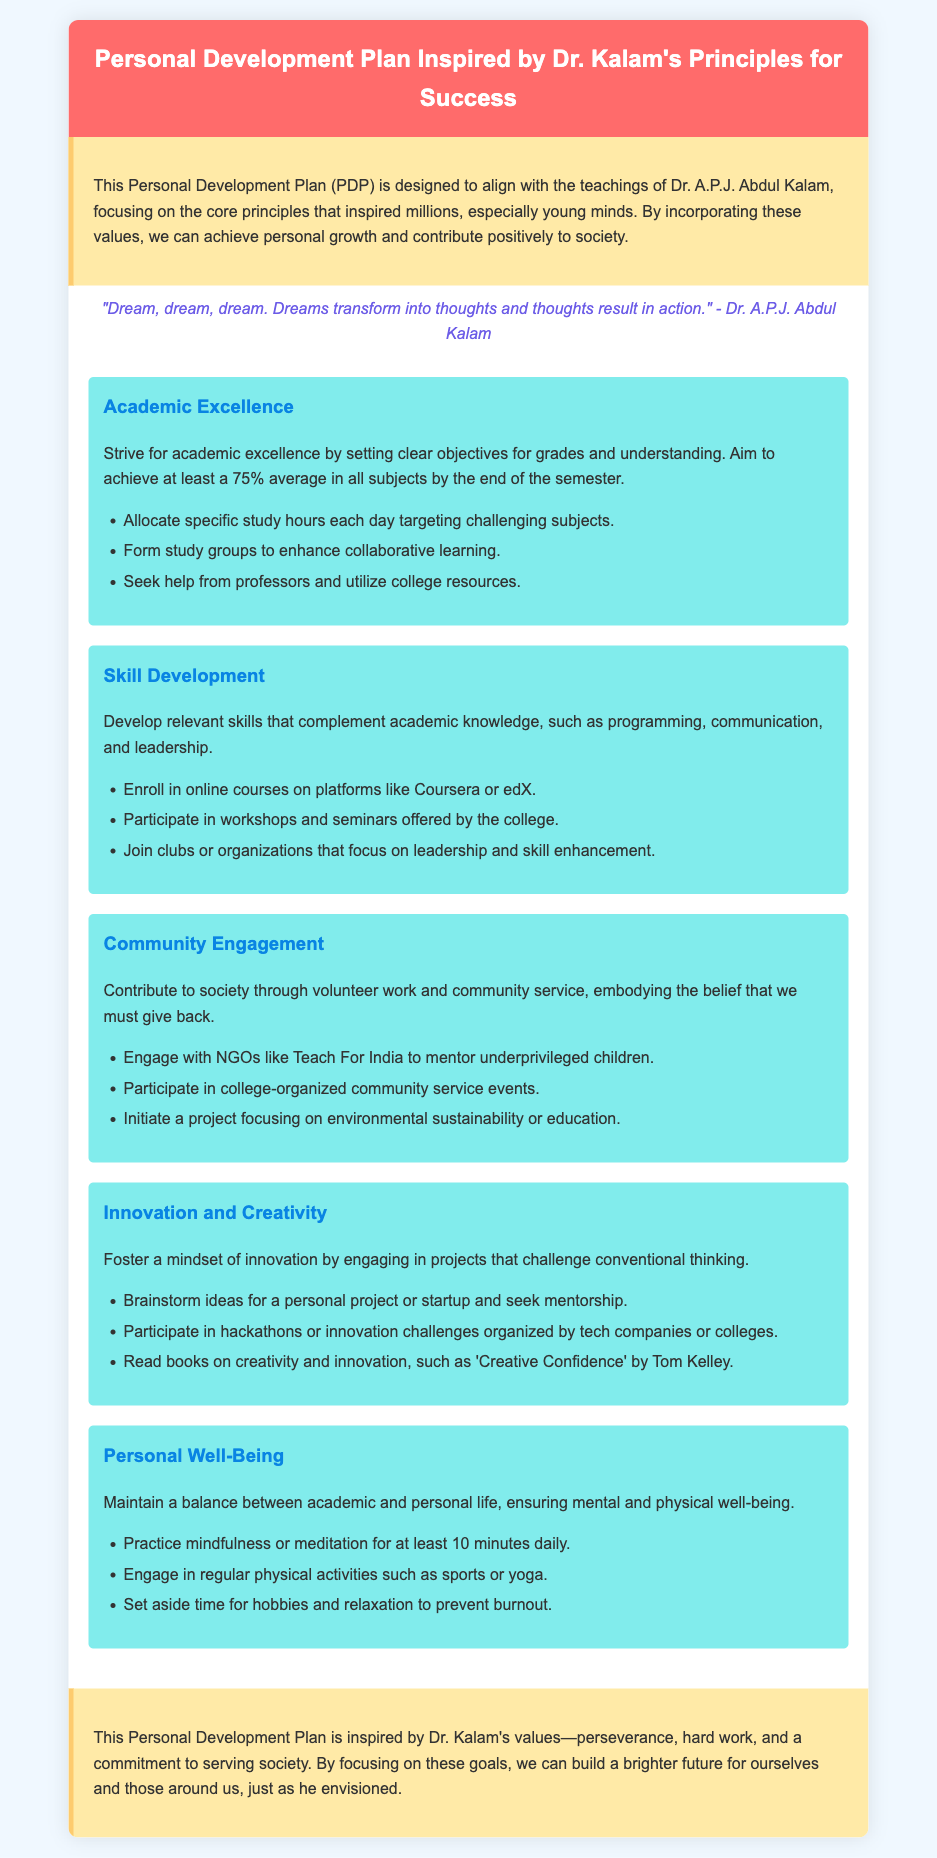What is the title of the document? The title is clearly stated in the header section of the document.
Answer: Personal Development Plan Inspired by Dr. Kalam's Principles for Success Who is the document inspired by? The document is designed based on the teachings of a prominent figure known for inspiring youth.
Answer: Dr. A.P.J. Abdul Kalam What is the goal for academic excellence? The document specifies a target for academic performance by the end of the semester.
Answer: 75% average Which skill development platforms are mentioned? Specific platforms for online courses are outlined in the skill development section.
Answer: Coursera, edX What type of community service is suggested? The document provides an example of an NGO to engage with for community service.
Answer: Teach For India How long should one practice mindfulness daily? The personal well-being section mentions a specific duration for mindfulness practice.
Answer: 10 minutes What does the quote from Dr. Kalam emphasize? The quote reflects a fundamental principle that leads to action from dreams.
Answer: Dreams transform into thoughts What is one goal related to personal well-being? The document lists several goals pertaining to maintaining personal health and balance.
Answer: Regular physical activities What should be achieved through innovation and creativity? The document indicates a desired mindset or outcome related to innovation.
Answer: A mindset of innovation 